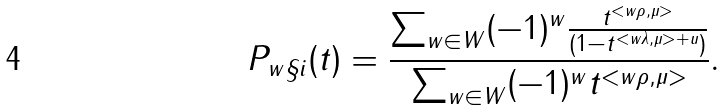Convert formula to latex. <formula><loc_0><loc_0><loc_500><loc_500>P _ { w \S i } ( t ) = \frac { \sum _ { w \in W } ( - 1 ) ^ { w } \frac { t ^ { < w \rho , \mu > } } { ( 1 - t ^ { < w \lambda , \mu > + u } ) } } { \sum _ { w \in W } ( - 1 ) ^ { w } t ^ { < w \rho , \mu > } } .</formula> 